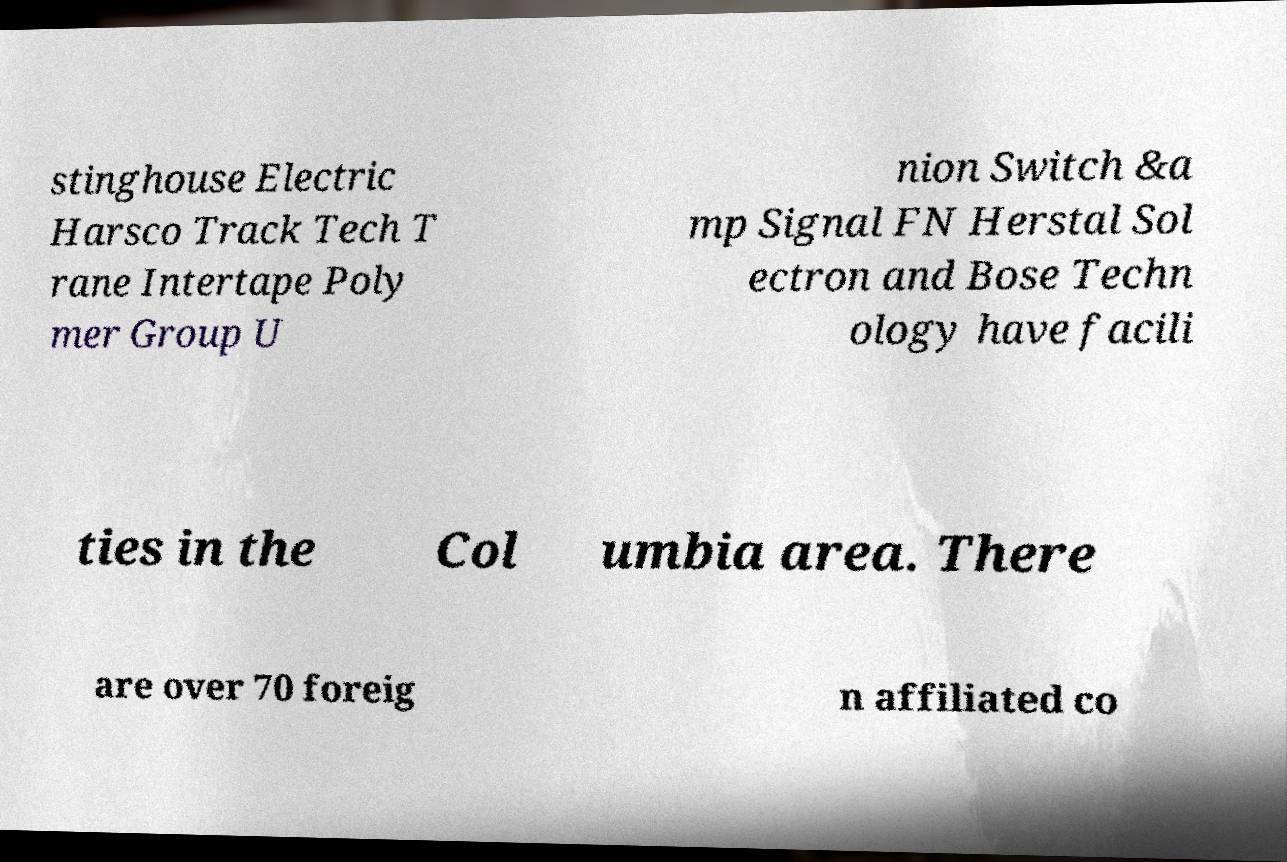Could you extract and type out the text from this image? stinghouse Electric Harsco Track Tech T rane Intertape Poly mer Group U nion Switch &a mp Signal FN Herstal Sol ectron and Bose Techn ology have facili ties in the Col umbia area. There are over 70 foreig n affiliated co 